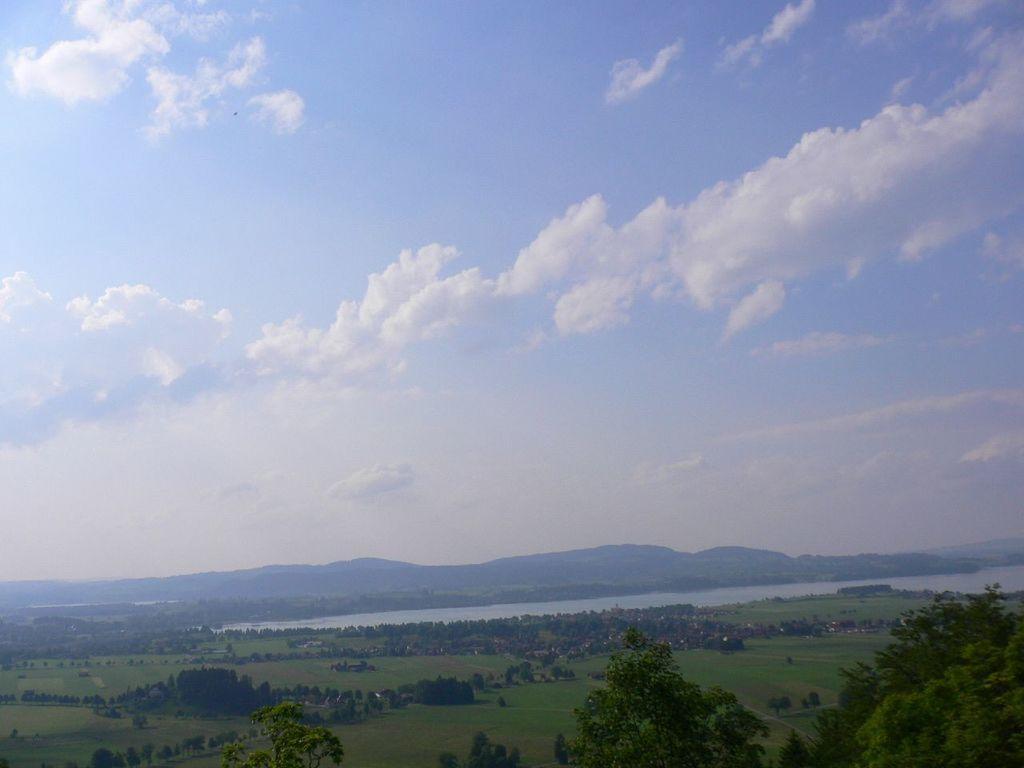Describe this image in one or two sentences. There are some trees on the grassy land as we can see at the bottom of this image. There is a sea and some mountains in the background. There is a cloudy sky at the top of this image. 